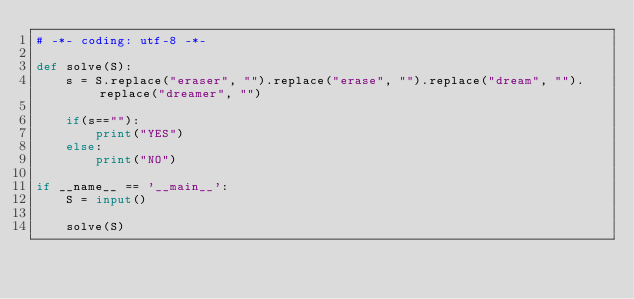Convert code to text. <code><loc_0><loc_0><loc_500><loc_500><_Python_># -*- coding: utf-8 -*-

def solve(S):
    s = S.replace("eraser", "").replace("erase", "").replace("dream", "").replace("dreamer", "")

    if(s==""):
        print("YES")
    else:
        print("NO")
    
if __name__ == '__main__':
    S = input()
  
    solve(S)</code> 